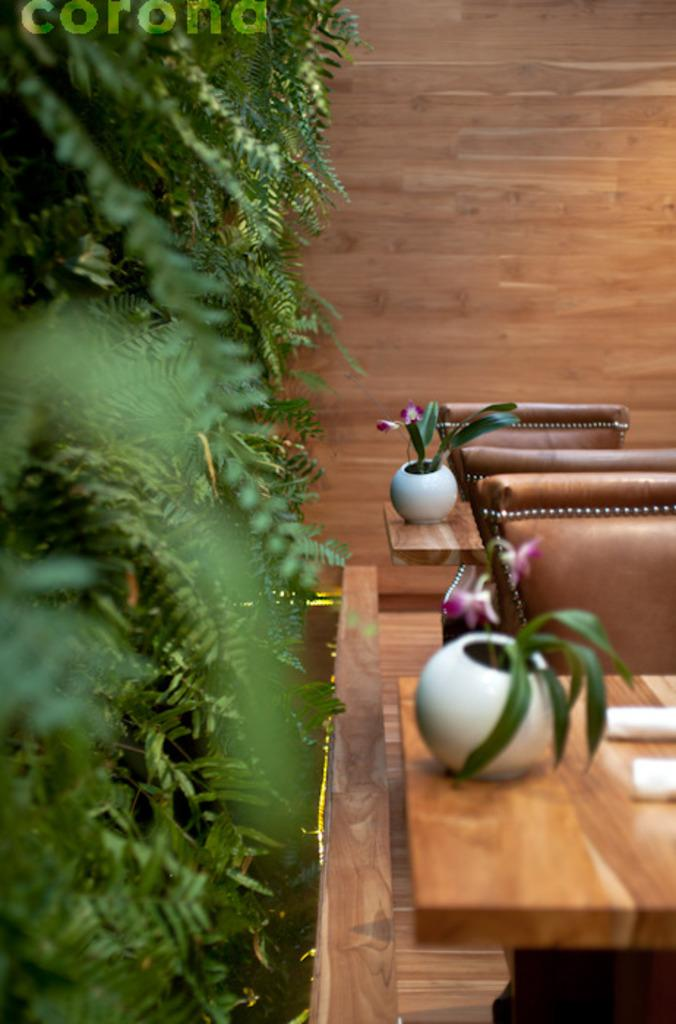What is located in the foreground of the image? There is a table, chairs, and houseplants in the foreground of the image. What can be seen in the background of the image? There are trees and a wooden wall in the background of the image. What might suggest that the image was taken during the day? The presence of natural light and shadows in the image suggests that it was likely taken during the day. How much profit did the judge make from the dock in the image? There is no dock, judge, or mention of profit in the image. The image features a table, chairs, houseplants, trees, and a wooden wall. 